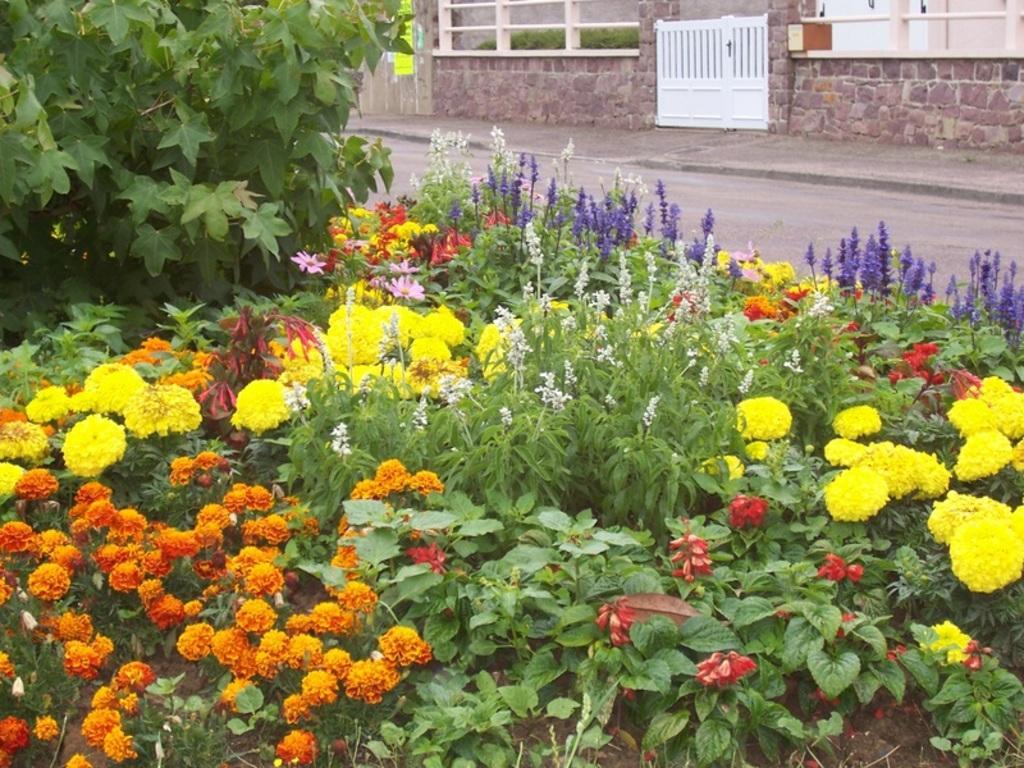Could you give a brief overview of what you see in this image? In the foreground of the image we can see different color flowers and plants. On the top of the image we can see road, wooden gate, rock's house and grass. 